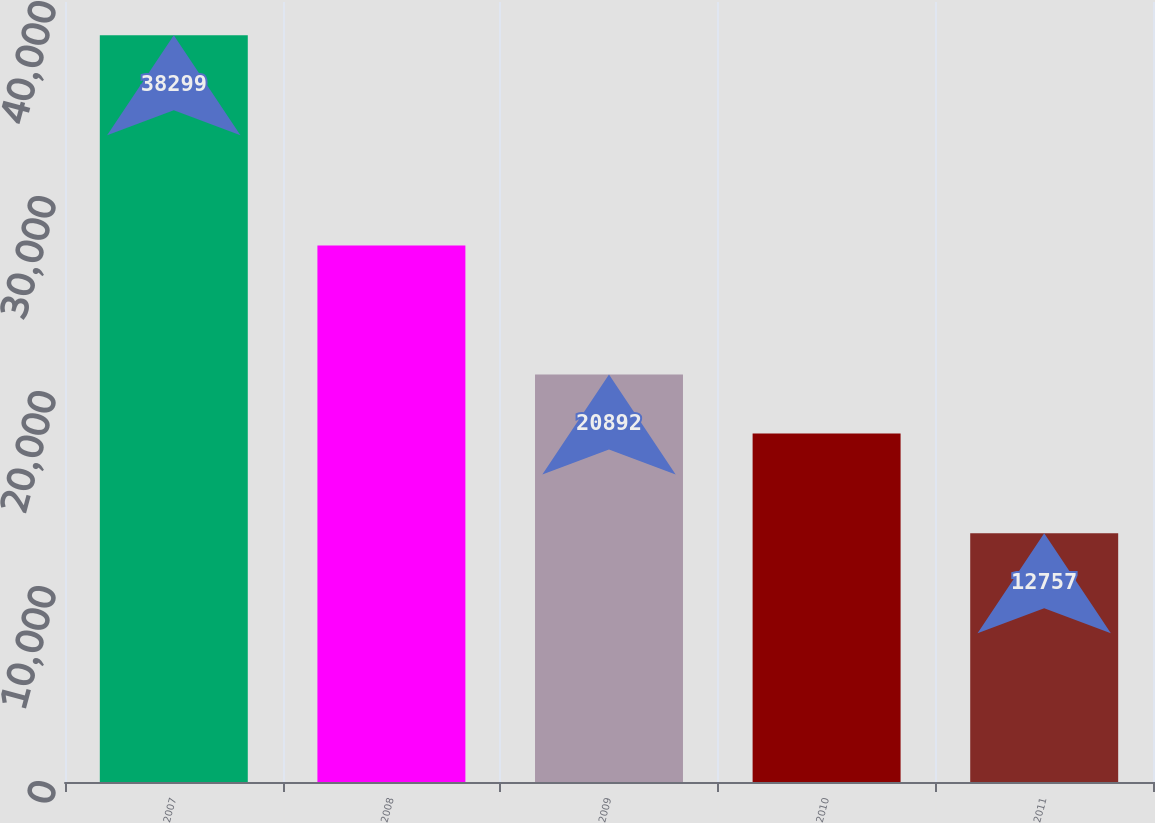<chart> <loc_0><loc_0><loc_500><loc_500><bar_chart><fcel>2007<fcel>2008<fcel>2009<fcel>2010<fcel>2011<nl><fcel>38299<fcel>27515<fcel>20892<fcel>17866<fcel>12757<nl></chart> 